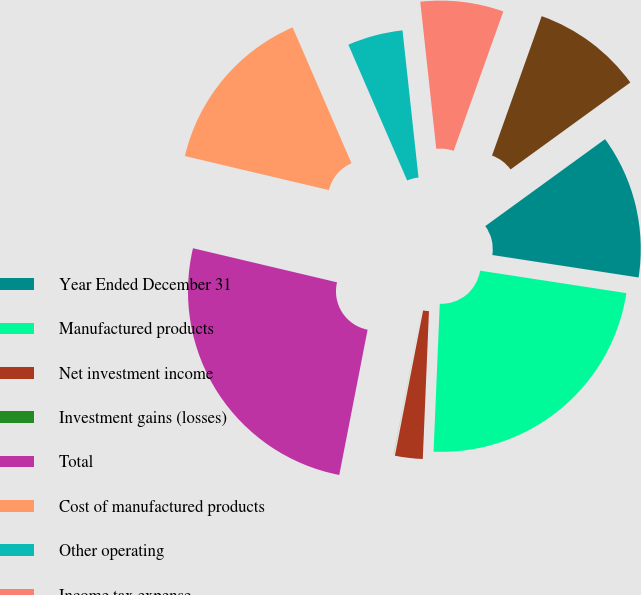<chart> <loc_0><loc_0><loc_500><loc_500><pie_chart><fcel>Year Ended December 31<fcel>Manufactured products<fcel>Net investment income<fcel>Investment gains (losses)<fcel>Total<fcel>Cost of manufactured products<fcel>Other operating<fcel>Income tax expense<fcel>Net income<nl><fcel>12.42%<fcel>23.24%<fcel>2.39%<fcel>0.01%<fcel>25.63%<fcel>14.8%<fcel>4.78%<fcel>7.17%<fcel>9.56%<nl></chart> 